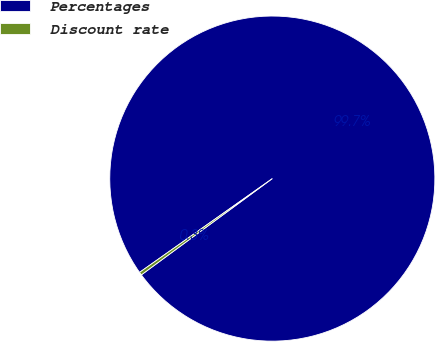<chart> <loc_0><loc_0><loc_500><loc_500><pie_chart><fcel>Percentages<fcel>Discount rate<nl><fcel>99.7%<fcel>0.3%<nl></chart> 